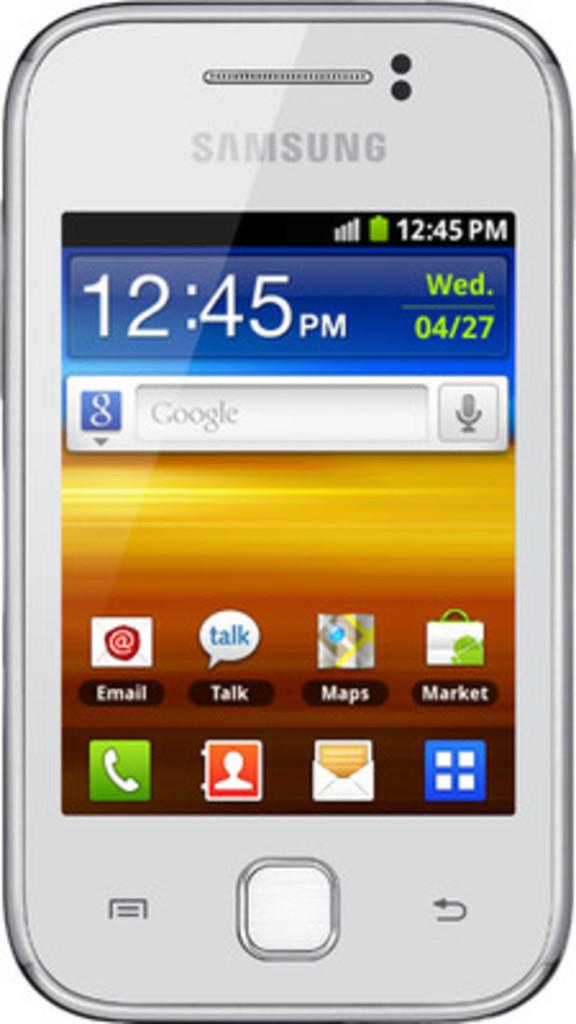What brand of mobile phone is visible in the image? There is a Samsung mobile phone in the image. What can be seen on the screen of the mobile phone? The mobile phone has apps and text displayed. What color is the background of the image? The background of the image is white. How many zebras are visible in the image? There are no zebras present in the image. What type of string is used to tie the mobile phone to the wall in the image? There is no string or wall mentioned in the image; it only shows a Samsung mobile phone with apps and text displayed on a white background. 